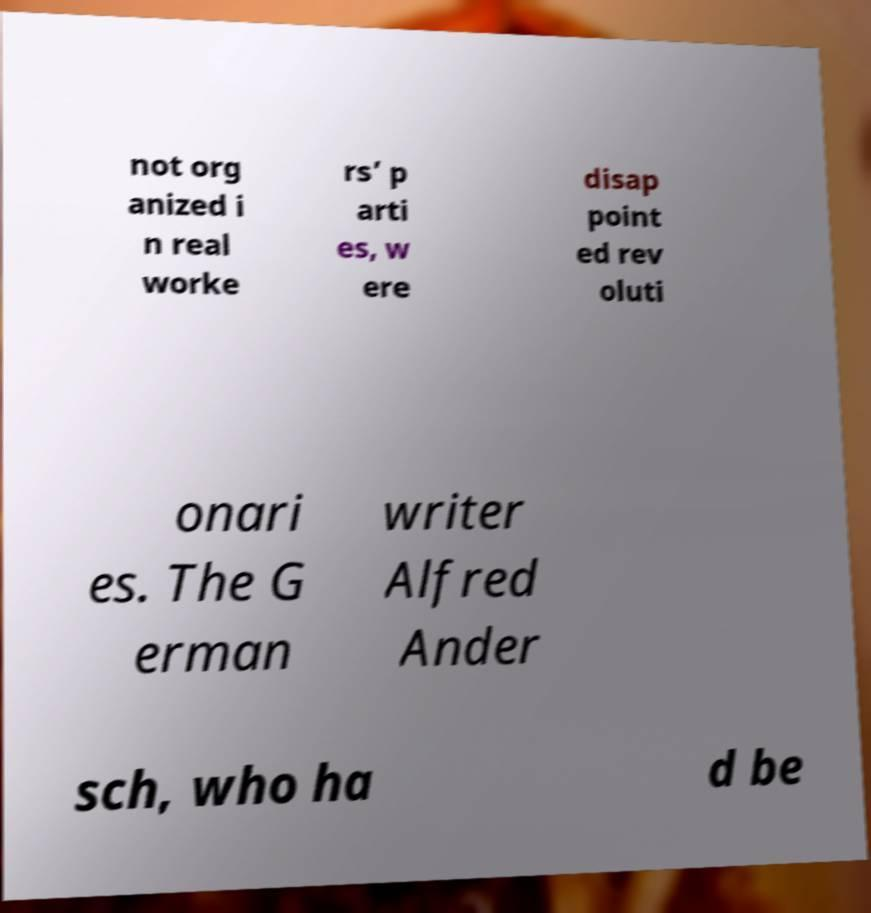Can you read and provide the text displayed in the image?This photo seems to have some interesting text. Can you extract and type it out for me? not org anized i n real worke rs’ p arti es, w ere disap point ed rev oluti onari es. The G erman writer Alfred Ander sch, who ha d be 